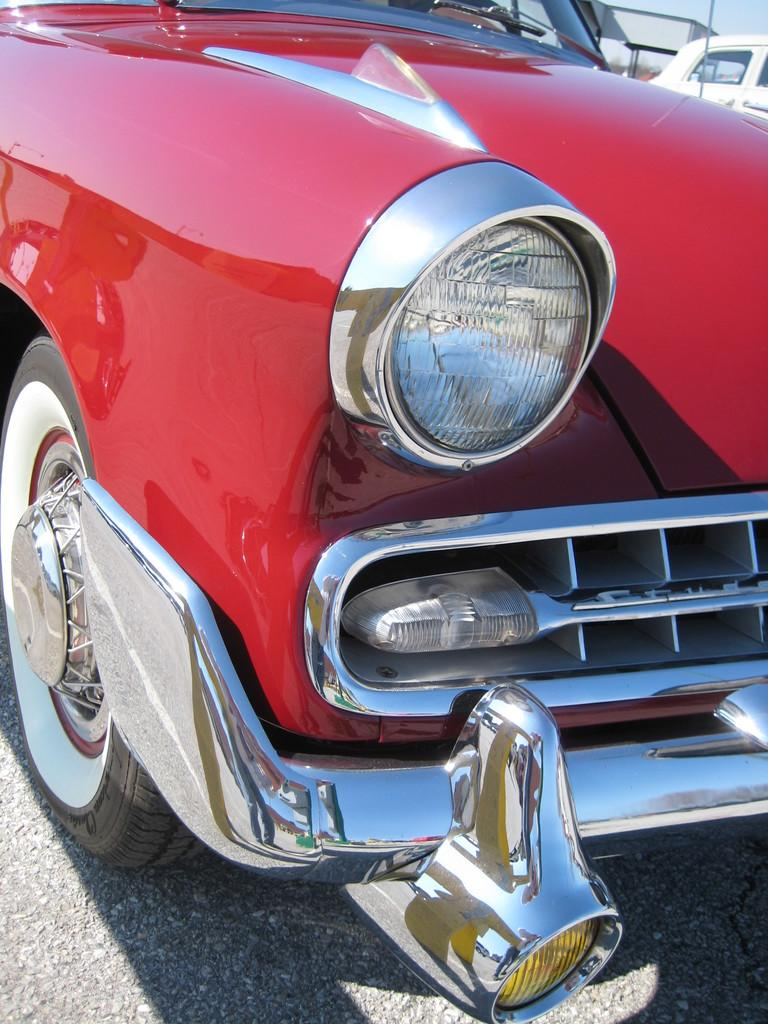What color is the car in the image? The car in the image is red. What is located at the bottom of the image? There is a road at the bottom of the image. What else can be seen in the background of the image besides the sky? There is a vehicle in the background of the image. What is visible in the top part of the image? The sky is visible in the background of the image. What type of property is being sold in the image? There is no property being sold in the image; it features a red car, a road, a vehicle in the background, and the sky. 